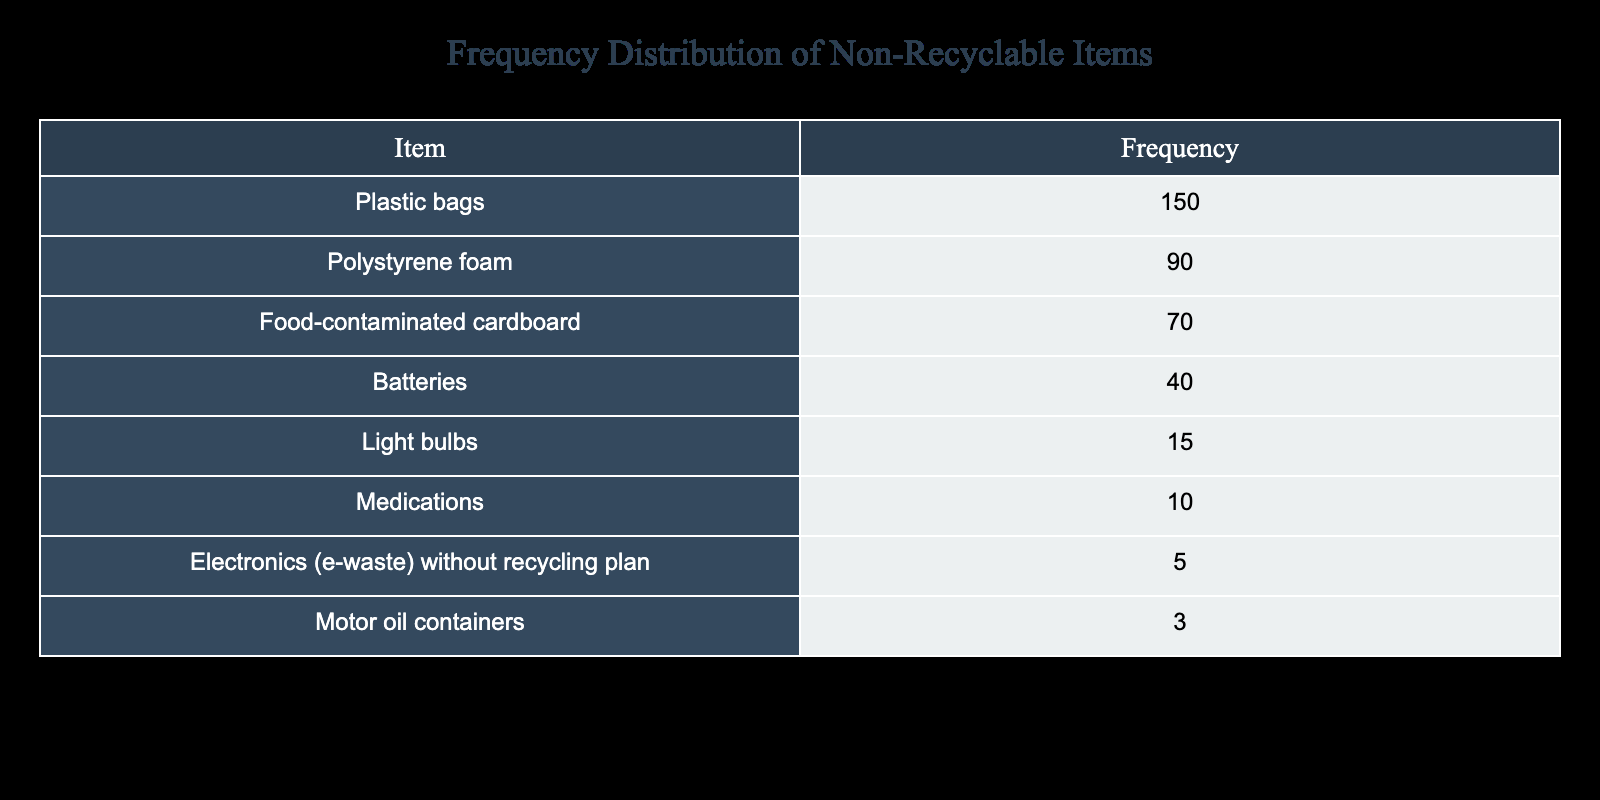What is the frequency of plastic bags? The table lists the frequency of plastic bags as 150. This information is found directly from the first row of the table under the "Frequency" column.
Answer: 150 Which item has the lowest frequency? By examining the "Frequency" column, we can see that motor oil containers have the lowest frequency of 3. This is found in the last row of the table.
Answer: 3 How many items have a frequency greater than 50? We can identify the items with a frequency greater than 50 by looking at the "Frequency" column. The items are: plastic bags (150), polystyrene foam (90), and food-contaminated cardboard (70), which totals three items.
Answer: 3 What is the total frequency of all non-recyclable items listed? To find the total frequency, we add up all the frequencies: 150 + 90 + 70 + 40 + 15 + 10 + 5 + 3 = 383. Hence, the sum of the frequencies gives us the total number of occurrences reported.
Answer: 383 Are there more food-contaminated cardboard items than batteries? Looking at the table, the frequency of food-contaminated cardboard is 70, while the frequency of batteries is 40. Since 70 is greater than 40, the answer is yes.
Answer: Yes What is the difference in frequency between polystyrene foam and electronics without a recycling plan? The frequency of polystyrene foam is 90, and electronics without a recycling plan is 5. The difference is calculated by subtracting: 90 - 5 = 85. This gives the direct comparison of their frequencies.
Answer: 85 What percentage of the total frequency does light bulbs represent? First, we find the frequency of light bulbs, which is 15. The total frequency we calculated earlier is 383. To find the percentage, we use the formula (15 / 383) * 100, which approximately equals 3.92%. This shows the proportion of light bulbs to the total.
Answer: Approximately 3.92% Is the frequency of medications greater than that of light bulbs? The table shows that the frequency of medications is 10 and for light bulbs is 15. Since 10 is not greater than 15, the answer is no.
Answer: No What is the total frequency of items that cannot be processed, excluding batteries? To find this total, we add all the frequencies except for batteries. The relevant frequencies are: 150 (plastic bags) + 90 (polystyrene foam) + 70 (food-contaminated cardboard) + 15 (light bulbs) + 10 (medications) + 5 (electronics) + 3 (motor oil containers) = 343. Thus, we obtain the total excluding batteries.
Answer: 343 